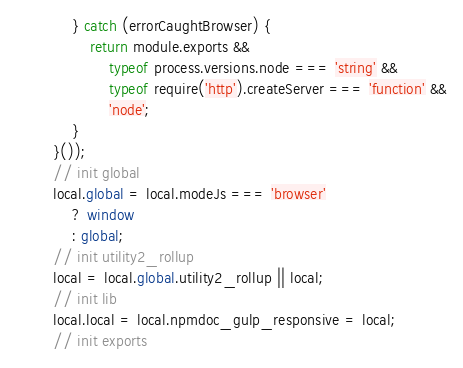Convert code to text. <code><loc_0><loc_0><loc_500><loc_500><_JavaScript_>            } catch (errorCaughtBrowser) {
                return module.exports &&
                    typeof process.versions.node === 'string' &&
                    typeof require('http').createServer === 'function' &&
                    'node';
            }
        }());
        // init global
        local.global = local.modeJs === 'browser'
            ? window
            : global;
        // init utility2_rollup
        local = local.global.utility2_rollup || local;
        // init lib
        local.local = local.npmdoc_gulp_responsive = local;
        // init exports</code> 